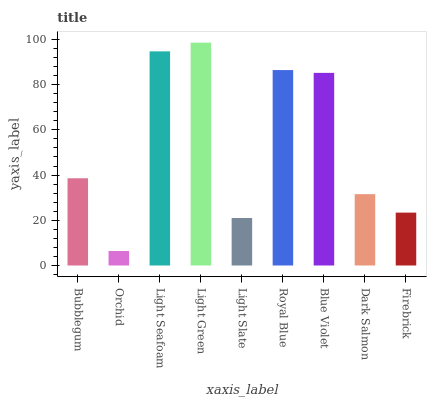Is Orchid the minimum?
Answer yes or no. Yes. Is Light Green the maximum?
Answer yes or no. Yes. Is Light Seafoam the minimum?
Answer yes or no. No. Is Light Seafoam the maximum?
Answer yes or no. No. Is Light Seafoam greater than Orchid?
Answer yes or no. Yes. Is Orchid less than Light Seafoam?
Answer yes or no. Yes. Is Orchid greater than Light Seafoam?
Answer yes or no. No. Is Light Seafoam less than Orchid?
Answer yes or no. No. Is Bubblegum the high median?
Answer yes or no. Yes. Is Bubblegum the low median?
Answer yes or no. Yes. Is Orchid the high median?
Answer yes or no. No. Is Light Green the low median?
Answer yes or no. No. 